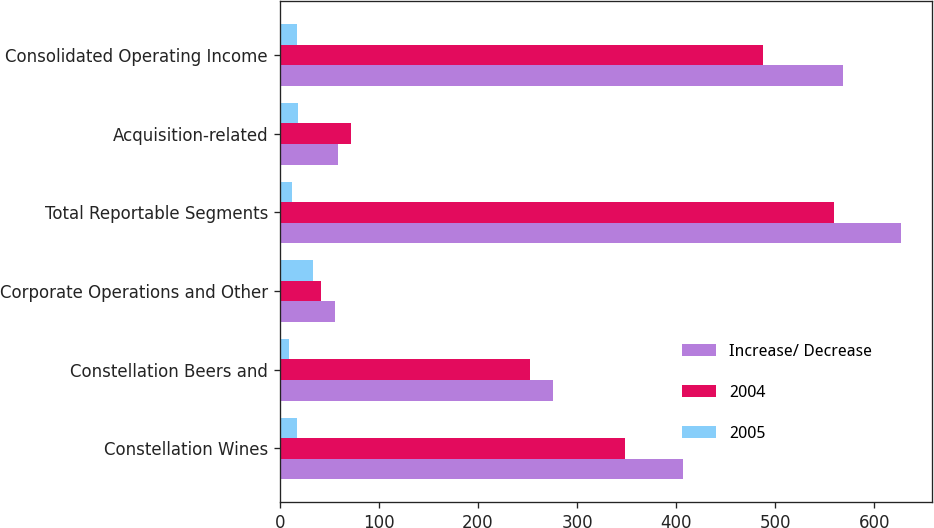<chart> <loc_0><loc_0><loc_500><loc_500><stacked_bar_chart><ecel><fcel>Constellation Wines<fcel>Constellation Beers and<fcel>Corporate Operations and Other<fcel>Total Reportable Segments<fcel>Acquisition-related<fcel>Consolidated Operating Income<nl><fcel>Increase/ Decrease<fcel>406.6<fcel>276.1<fcel>56<fcel>626.7<fcel>58.8<fcel>567.9<nl><fcel>2004<fcel>348.1<fcel>252.5<fcel>41.7<fcel>558.9<fcel>71.5<fcel>487.4<nl><fcel>2005<fcel>17<fcel>9<fcel>34<fcel>12<fcel>18<fcel>17<nl></chart> 